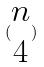<formula> <loc_0><loc_0><loc_500><loc_500>( \begin{matrix} n \\ 4 \end{matrix} )</formula> 